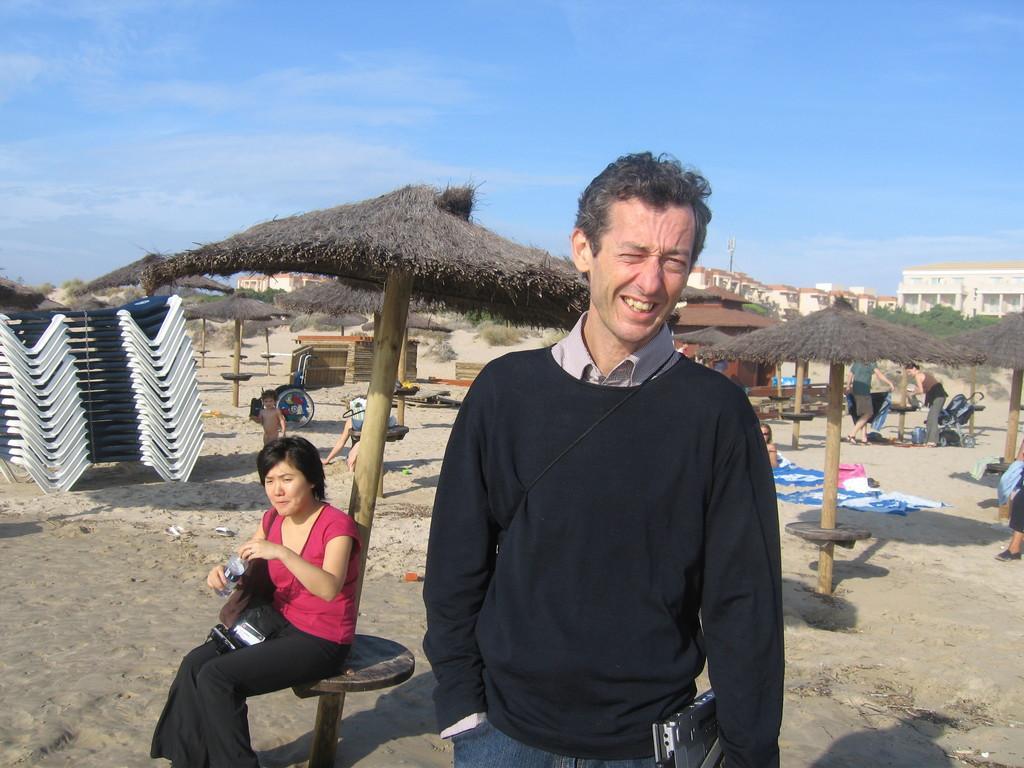Could you give a brief overview of what you see in this image? In this image there are people, it looks like umbrellas and there are some objects in the foreground. There are buildings in the background. There is mud floor at the bottom. And there is sky at the top. 